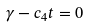Convert formula to latex. <formula><loc_0><loc_0><loc_500><loc_500>\gamma - c _ { 4 } t = 0</formula> 